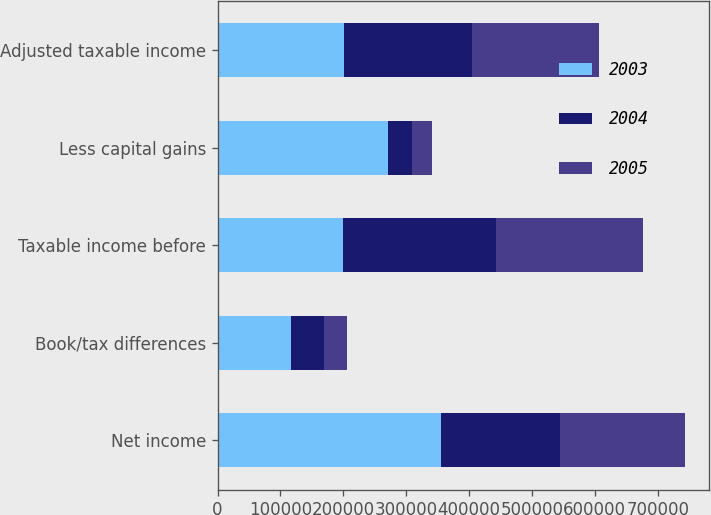Convert chart to OTSL. <chart><loc_0><loc_0><loc_500><loc_500><stacked_bar_chart><ecel><fcel>Net income<fcel>Book/tax differences<fcel>Taxable income before<fcel>Less capital gains<fcel>Adjusted taxable income<nl><fcel>2003<fcel>355662<fcel>116152<fcel>200096<fcel>270854<fcel>200960<nl><fcel>2004<fcel>188701<fcel>53817<fcel>242518<fcel>38655<fcel>203863<nl><fcel>2005<fcel>199232<fcel>35082<fcel>234314<fcel>32009<fcel>202305<nl></chart> 